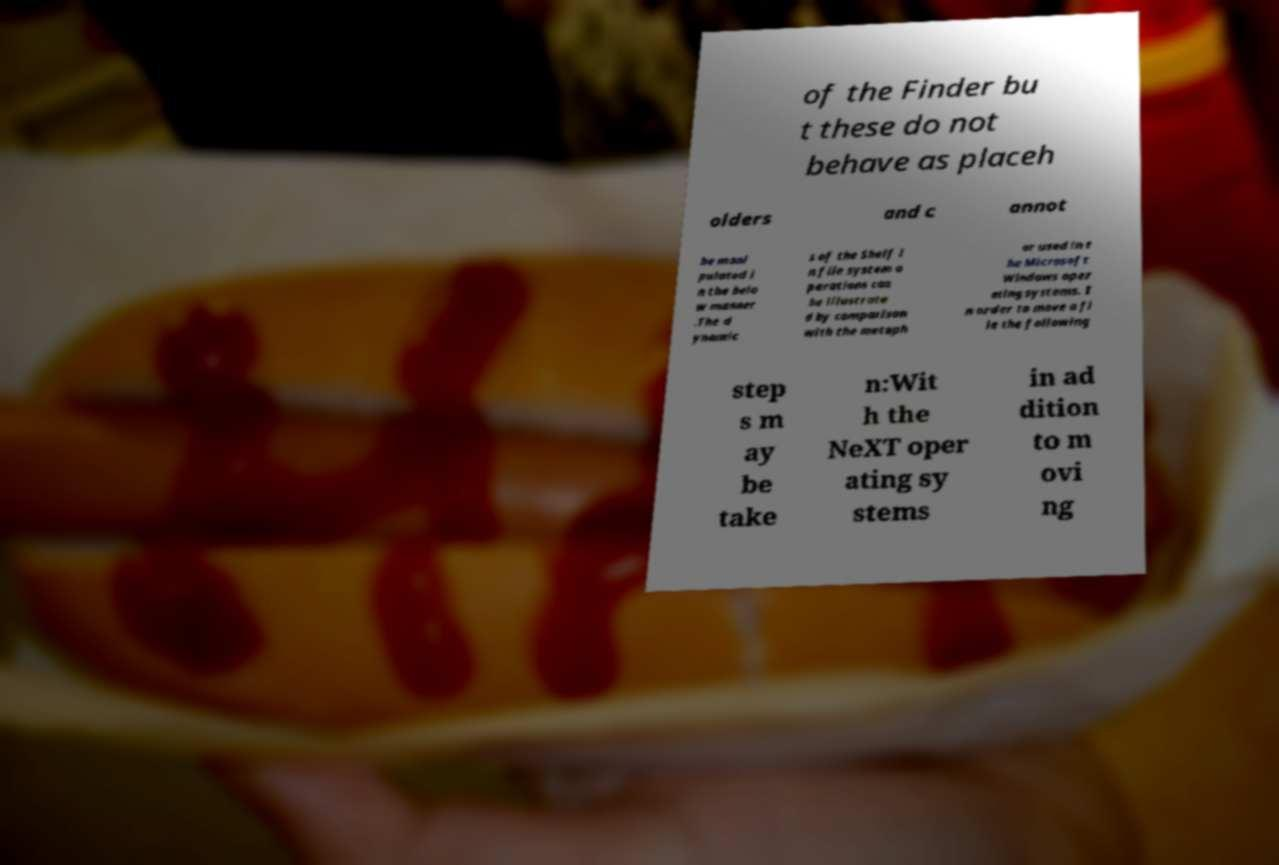Can you accurately transcribe the text from the provided image for me? of the Finder bu t these do not behave as placeh olders and c annot be mani pulated i n the belo w manner .The d ynamic s of the Shelf i n file system o perations can be illustrate d by comparison with the metaph or used in t he Microsoft Windows oper ating systems. I n order to move a fi le the following step s m ay be take n:Wit h the NeXT oper ating sy stems in ad dition to m ovi ng 